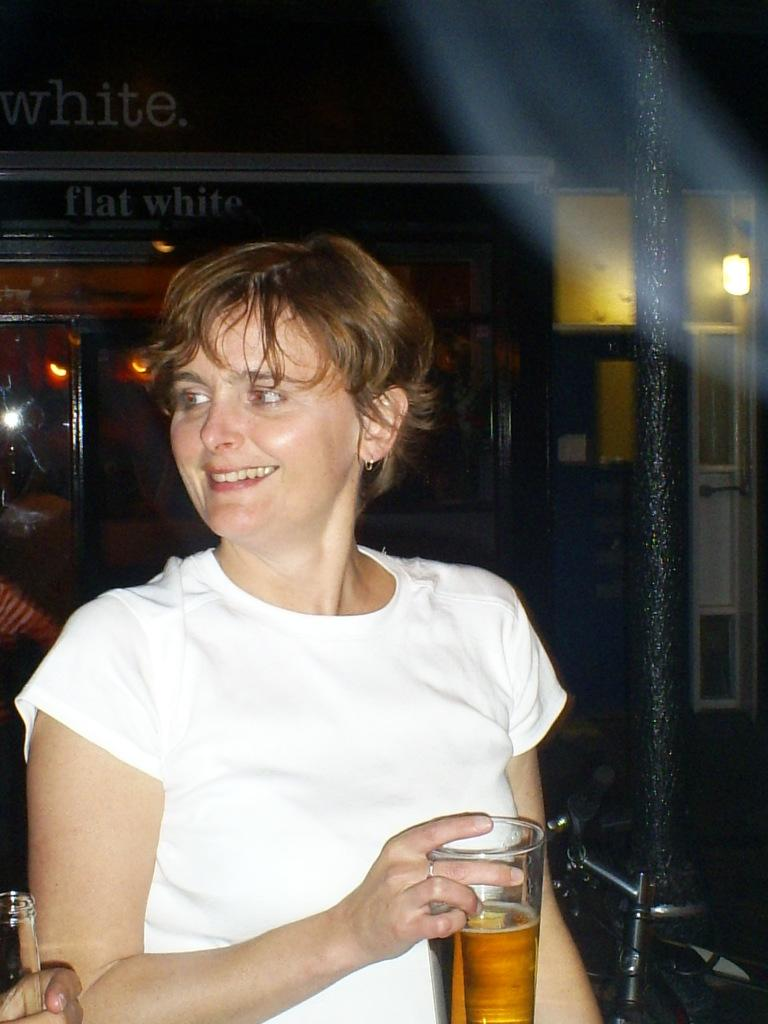Who is the main subject in the image? There is a woman in the image. Where is the woman located in the image? The woman is in the center of the image. What is the woman holding in her right hand? The woman is holding a glass of wine in her right hand. What is the woman's facial expression in the image? The woman is smiling. What type of band is playing in the background of the image? There is no band present in the image; it only features a woman holding a glass of wine. 